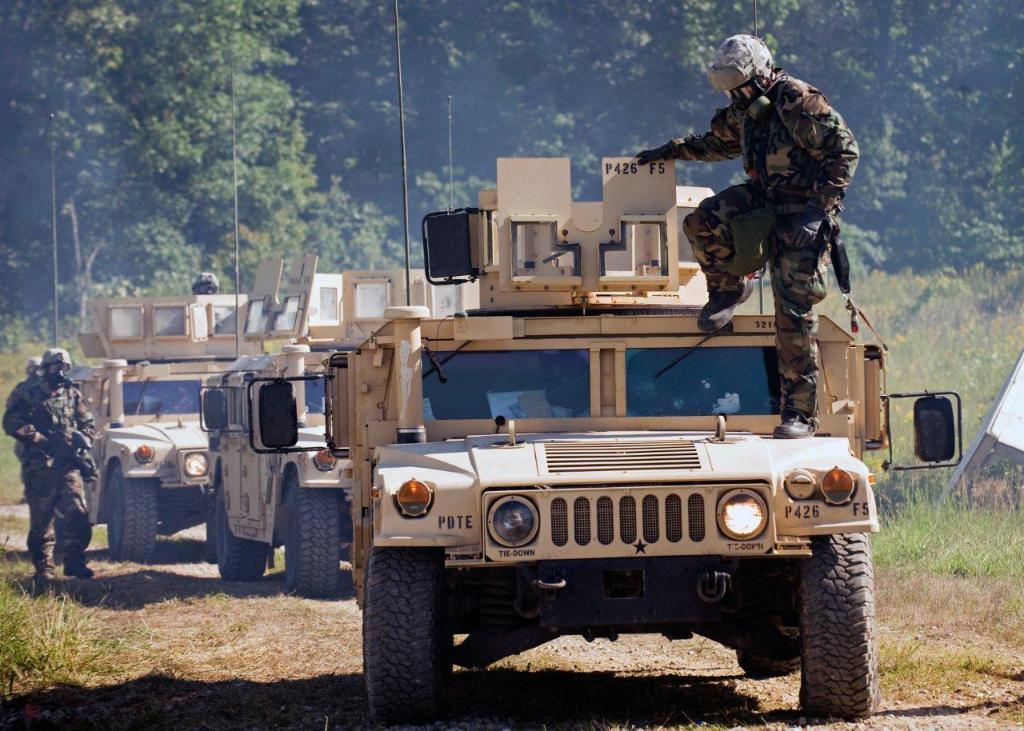How would you summarize this image in a sentence or two? In this picture we can see vehicles, soldiers, path and grass. In the background there are trees. 